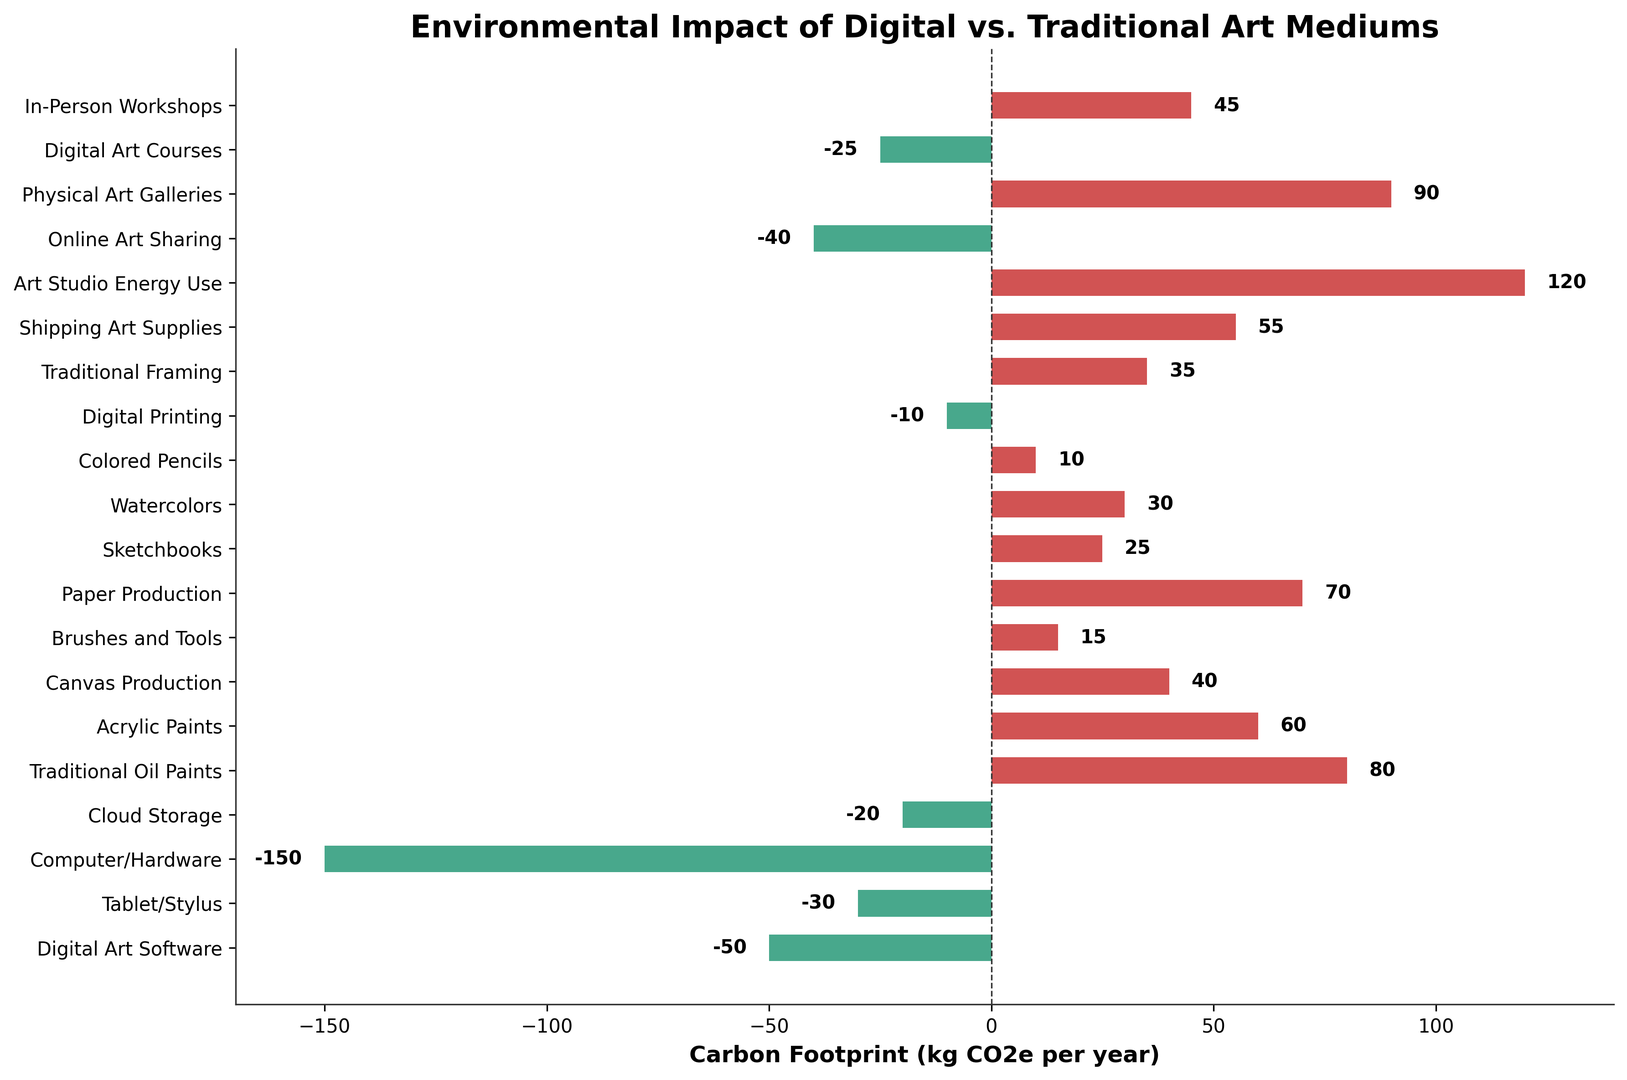What is the medium with the highest carbon footprint? The highest bar among the positive values indicates the highest carbon footprint. Art Studio Energy Use has the highest bar with a carbon footprint of 120 kg CO2e per year.
Answer: Art Studio Energy Use Which digital art medium contributes the most to reducing carbon footprint? Among the negative values (indicating carbon footprint reduction), the lowest bar represents the greatest reduction. Computer/Hardware has the lowest bar with -150 kg CO2e per year.
Answer: Computer/Hardware What is the combined carbon footprint of Traditional Oil Paints and Shipping Art Supplies? Add the carbon footprints of Traditional Oil Paints (80) and Shipping Art Supplies (55). The combined carbon footprint is 80 + 55 = 135 kg CO2e per year.
Answer: 135 kg CO2e per year Which traditional art medium has the lowest carbon footprint? Among the positive values for traditional art mediums, the smallest bar represents the lowest carbon footprint. Brushes and Tools have a carbon footprint of 15 kg CO2e per year.
Answer: Brushes and Tools How much more carbon does Physical Art Galleries contribute compared to Digital Art Courses? Subtract the carbon footprint of Digital Art Courses (-25) from Physical Art Galleries (90). The difference is 90 - (-25) = 115 kg CO2e per year.
Answer: 115 kg CO2e per year What is the average carbon footprint of Canvas Production, Paper Production, and Sketchbooks? Sum the carbon footprints of Canvas Production (40), Paper Production (70), and Sketchbooks (25), then divide by 3. The average is (40 + 70 + 25) / 3 = 45 kg CO2e per year.
Answer: 45 kg CO2e per year Which category, digital or traditional art, generally has higher carbon footprints based on visual inspection? Most bars for traditional art mediums are positive, indicating a higher carbon footprint, whereas many digital art mediums have negative values, indicating a reduction in carbon footprint.
Answer: Traditional art What is the total amount of carbon footprint reduction from all digital art mediums listed? Sum the negative values for digital art mediums: Digital Art Software (-50), Tablet/Stylus (-30), Computer/Hardware (-150), Cloud Storage (-20), Digital Printing (-10), Online Art Sharing (-40), Digital Art Courses (-25). The total reduction is -325 kg CO2e per year.
Answer: -325 kg CO2e per year Which has a higher carbon footprint: Acrylic Paints or In-Person Workshops? Compare the bars for Acrylic Paints (60) and In-Person Workshops (45). The bar for Acrylic Paints is higher, indicating a larger carbon footprint.
Answer: Acrylic Paints What is the difference in carbon footprint between Digital Art Software and Traditional Framing? Subtract the carbon footprint of Digital Art Software (-50) from Traditional Framing (35). The difference is 35 - (-50) = 85 kg CO2e per year.
Answer: 85 kg CO2e per year 